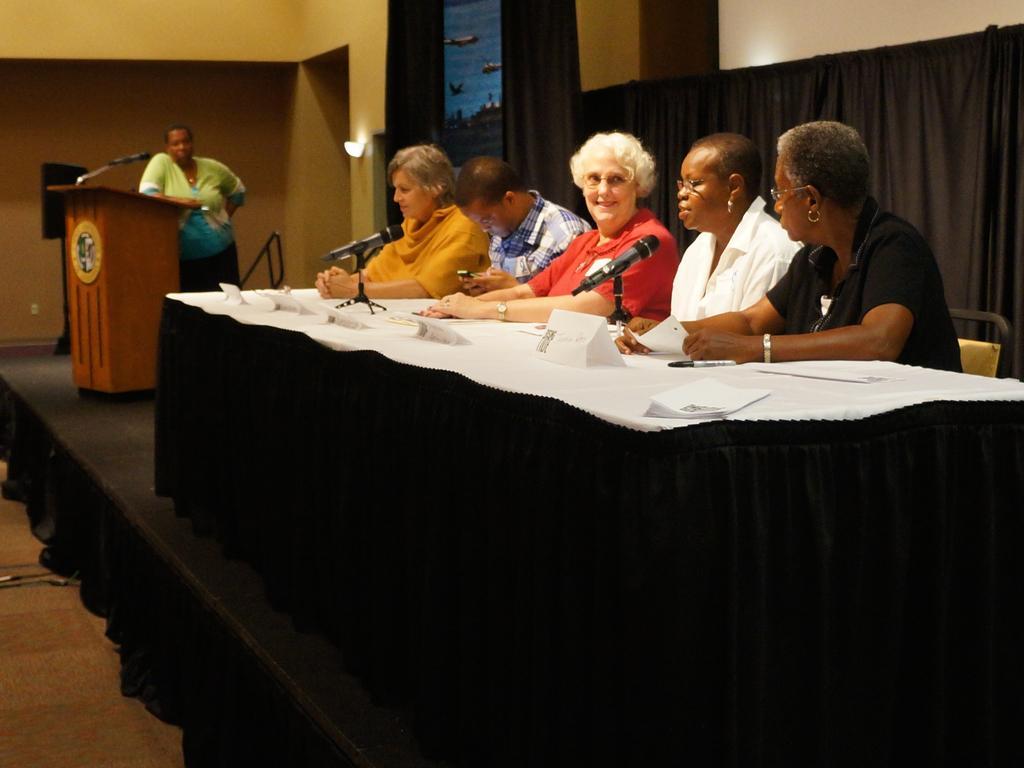Please provide a concise description of this image. In the image we can see there are people who are sitting on chair and on the other side there is a person standing. 